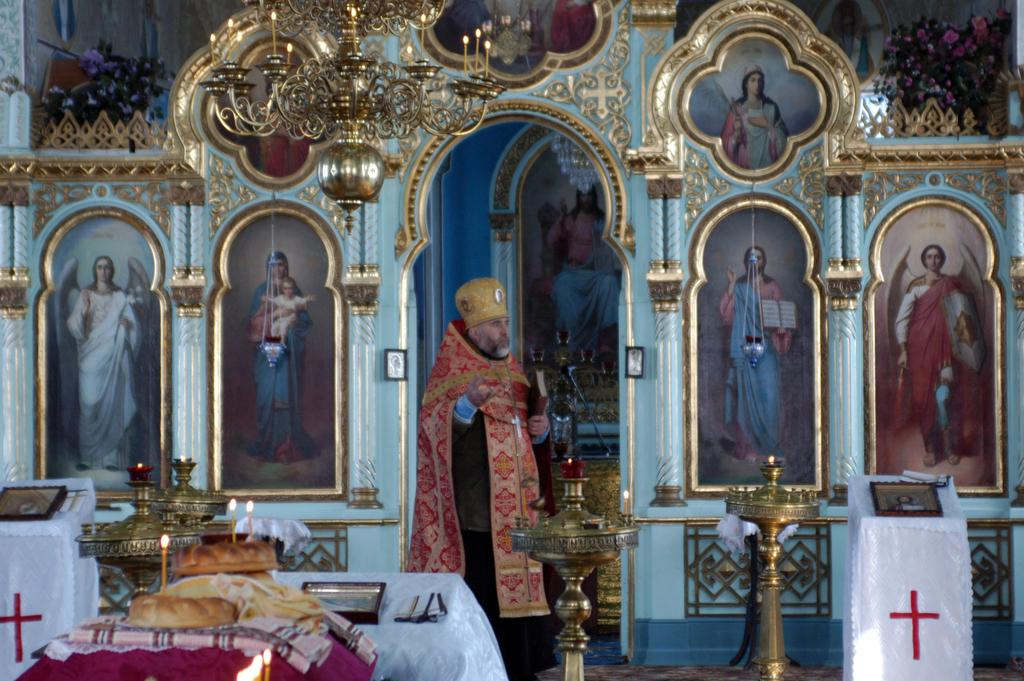What is the primary subject in the room? There is a person standing in the room. What objects can be seen in the room that provide light? There are candles in the room. What type of furniture is present in the room? There are tables in the room. What items can be seen on the walls in the room? There are photo frames in the room. How many toes can be seen on the person's feet in the image? There is no information about the person's feet or toes in the image, so it cannot be determined. 